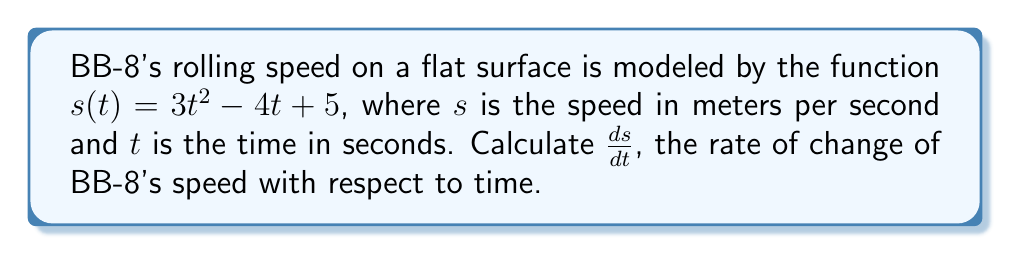Help me with this question. To find the derivative of $s(t)$ with respect to $t$, we'll use the power rule and the constant rule:

1. For the term $3t^2$:
   The power rule states that $\frac{d}{dx}(x^n) = nx^{n-1}$
   So, $\frac{d}{dt}(3t^2) = 3 \cdot 2t^{2-1} = 6t$

2. For the term $-4t$:
   The power rule gives us $\frac{d}{dt}(-4t) = -4$

3. For the constant term 5:
   The derivative of a constant is always 0, so $\frac{d}{dt}(5) = 0$

Now, we add these results together:

$$\frac{ds}{dt} = 6t - 4 + 0 = 6t - 4$$

This represents the instantaneous rate of change of BB-8's speed at any given time $t$.
Answer: $\frac{ds}{dt} = 6t - 4$ 